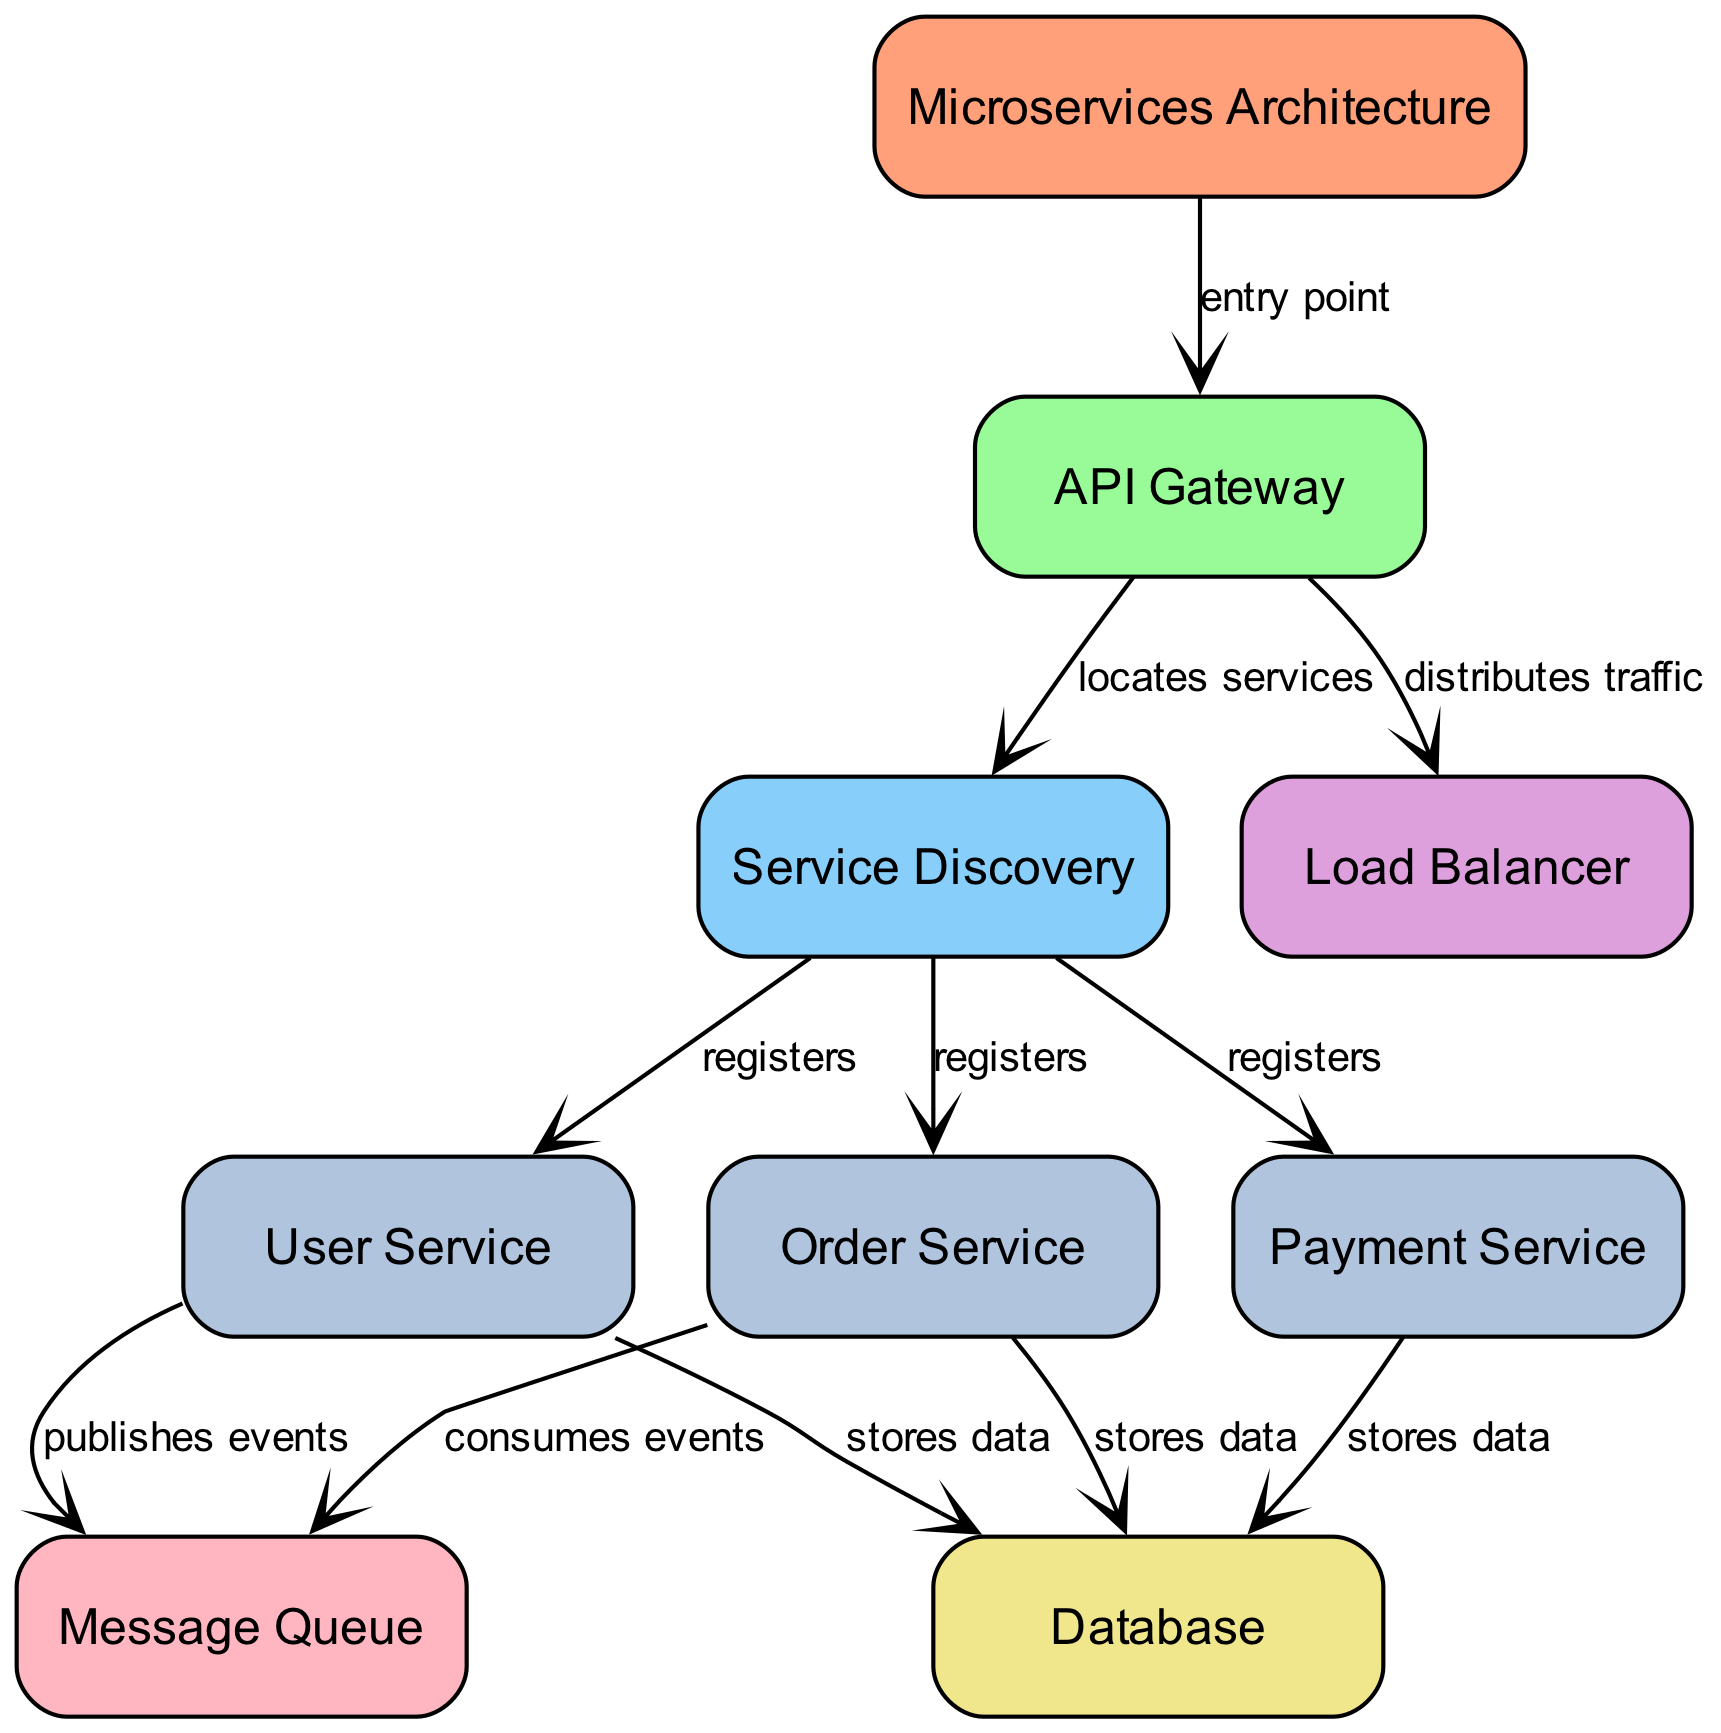What is the entry point to the Microservices Architecture? The diagram shows that the API Gateway is labeled as the entry point to the Microservices Architecture. It is the first component that interacts with incoming requests.
Answer: API Gateway How many services are registered with the Service Discovery? The diagram indicates that there are three services (User Service, Order Service, Payment Service) registered with the Service Discovery, as shown by the connections from Service Discovery to each service.
Answer: 3 Which service publishes events to the Message Queue? According to the diagram, the User Service is indicated as publishing events to the Message Queue, as denoted by the edge connecting the User Service to the Message Queue.
Answer: User Service What component is responsible for distributing traffic? The Load Balancer is shown in the diagram as the component that distributes traffic, based on the edge coming from the API Gateway to the Load Balancer labeled "distributes traffic."
Answer: Load Balancer Which services store data in the Database? The diagram highlights that all three services (User Service, Order Service, Payment Service) store data in the Database, as indicated by the edges from each service to the Database labeled "stores data."
Answer: User Service, Order Service, Payment Service What role does the API Gateway play in finding services? The API Gateway's role in locating services is explained by the edge connecting it to the Service Discovery, labeled "locates services." This shows that it relies on Service Discovery to find the available services.
Answer: Locates services Which service consumes events from the Message Queue? The diagram specifies that the Order Service is the service that consumes events from the Message Queue, as indicated by the edge flowing from the Message Queue to the Order Service labeled "consumes events."
Answer: Order Service How does the User Service interact with the Message Queue? The diagram reveals that the User Service interacts with the Message Queue by publishing events to it, shown by an edge directed from the User Service to the Message Queue labeled "publishes events."
Answer: Publishes events What is the color representation for the Load Balancer in the diagram? The Load Balancer is represented in a light purple color (DDA0DD) according to the color scheme defined in the diagram, highlighting its distinct component role.
Answer: Light purple 